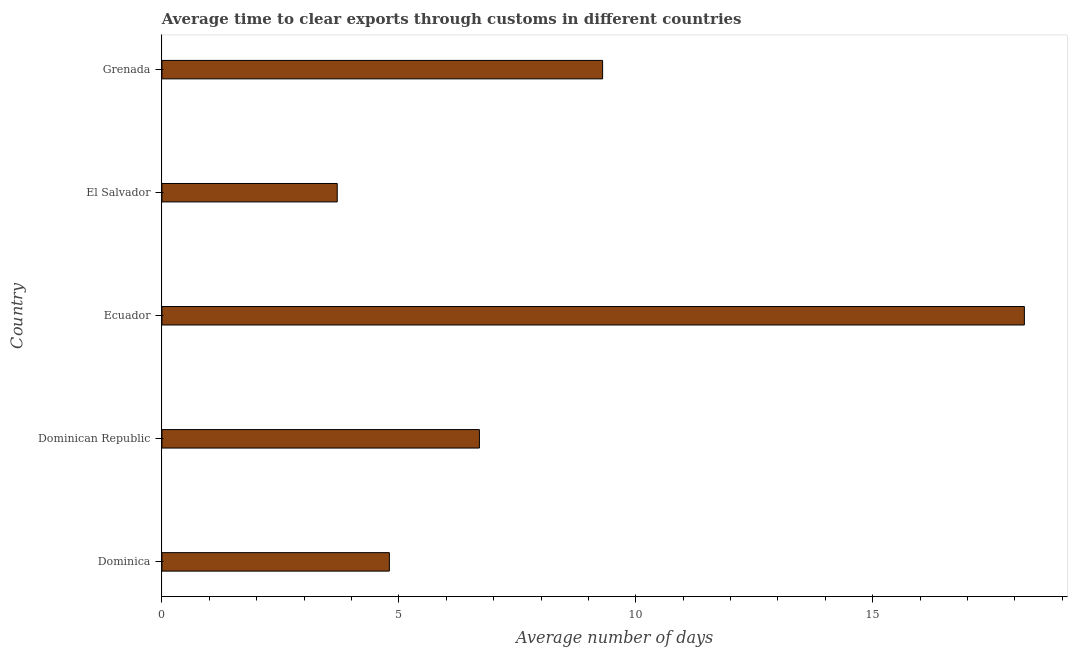Does the graph contain grids?
Your response must be concise. No. What is the title of the graph?
Ensure brevity in your answer.  Average time to clear exports through customs in different countries. What is the label or title of the X-axis?
Provide a short and direct response. Average number of days. What is the label or title of the Y-axis?
Give a very brief answer. Country. Across all countries, what is the maximum time to clear exports through customs?
Offer a terse response. 18.2. Across all countries, what is the minimum time to clear exports through customs?
Keep it short and to the point. 3.7. In which country was the time to clear exports through customs maximum?
Offer a very short reply. Ecuador. In which country was the time to clear exports through customs minimum?
Provide a succinct answer. El Salvador. What is the sum of the time to clear exports through customs?
Give a very brief answer. 42.7. What is the average time to clear exports through customs per country?
Provide a succinct answer. 8.54. What is the median time to clear exports through customs?
Give a very brief answer. 6.7. What is the ratio of the time to clear exports through customs in Ecuador to that in El Salvador?
Ensure brevity in your answer.  4.92. Is the difference between the time to clear exports through customs in Dominican Republic and El Salvador greater than the difference between any two countries?
Ensure brevity in your answer.  No. What is the difference between the highest and the second highest time to clear exports through customs?
Offer a very short reply. 8.9. What is the difference between the highest and the lowest time to clear exports through customs?
Offer a very short reply. 14.5. How many countries are there in the graph?
Make the answer very short. 5. What is the difference between two consecutive major ticks on the X-axis?
Offer a terse response. 5. What is the Average number of days in Dominican Republic?
Provide a succinct answer. 6.7. What is the Average number of days in Ecuador?
Give a very brief answer. 18.2. What is the Average number of days in El Salvador?
Offer a terse response. 3.7. What is the difference between the Average number of days in Dominica and Ecuador?
Provide a succinct answer. -13.4. What is the difference between the Average number of days in Dominica and El Salvador?
Your answer should be compact. 1.1. What is the difference between the Average number of days in Dominica and Grenada?
Offer a terse response. -4.5. What is the difference between the Average number of days in Dominican Republic and Ecuador?
Ensure brevity in your answer.  -11.5. What is the difference between the Average number of days in Dominican Republic and El Salvador?
Provide a succinct answer. 3. What is the difference between the Average number of days in Ecuador and El Salvador?
Your response must be concise. 14.5. What is the difference between the Average number of days in Ecuador and Grenada?
Provide a short and direct response. 8.9. What is the difference between the Average number of days in El Salvador and Grenada?
Provide a succinct answer. -5.6. What is the ratio of the Average number of days in Dominica to that in Dominican Republic?
Your response must be concise. 0.72. What is the ratio of the Average number of days in Dominica to that in Ecuador?
Provide a short and direct response. 0.26. What is the ratio of the Average number of days in Dominica to that in El Salvador?
Your answer should be compact. 1.3. What is the ratio of the Average number of days in Dominica to that in Grenada?
Keep it short and to the point. 0.52. What is the ratio of the Average number of days in Dominican Republic to that in Ecuador?
Your response must be concise. 0.37. What is the ratio of the Average number of days in Dominican Republic to that in El Salvador?
Offer a terse response. 1.81. What is the ratio of the Average number of days in Dominican Republic to that in Grenada?
Your answer should be very brief. 0.72. What is the ratio of the Average number of days in Ecuador to that in El Salvador?
Your answer should be compact. 4.92. What is the ratio of the Average number of days in Ecuador to that in Grenada?
Your answer should be compact. 1.96. What is the ratio of the Average number of days in El Salvador to that in Grenada?
Offer a terse response. 0.4. 